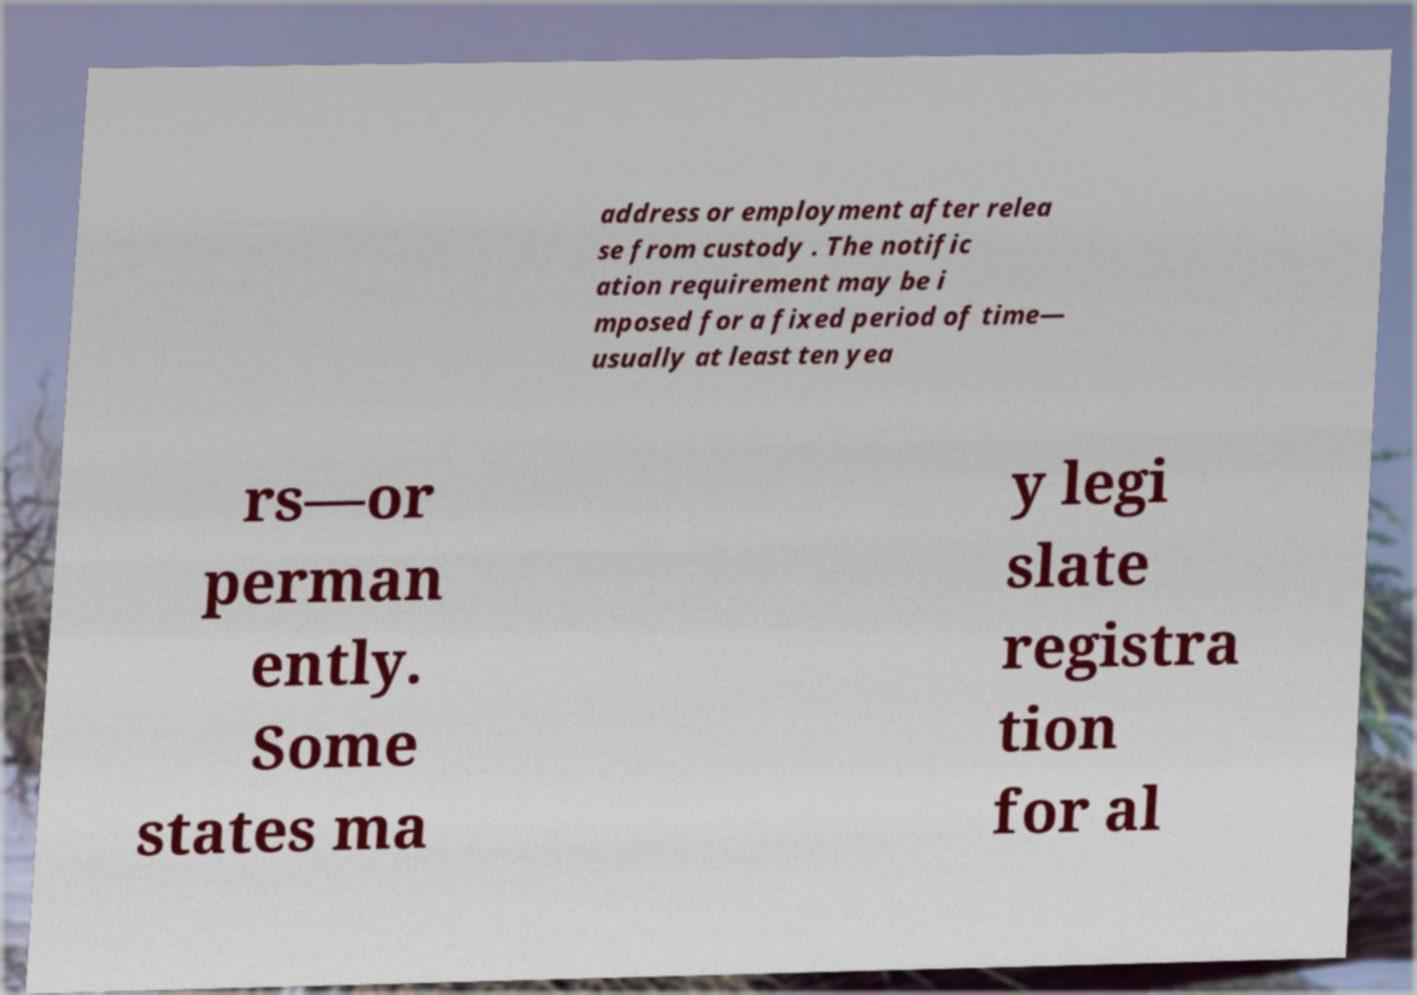I need the written content from this picture converted into text. Can you do that? address or employment after relea se from custody . The notific ation requirement may be i mposed for a fixed period of time— usually at least ten yea rs—or perman ently. Some states ma y legi slate registra tion for al 